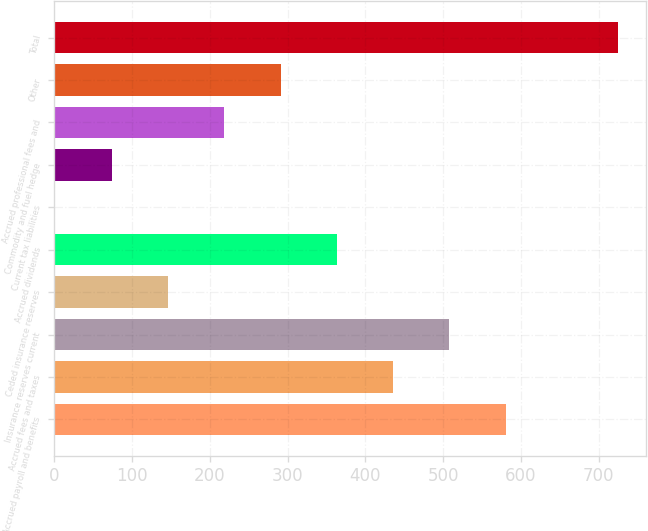Convert chart. <chart><loc_0><loc_0><loc_500><loc_500><bar_chart><fcel>Accrued payroll and benefits<fcel>Accrued fees and taxes<fcel>Insurance reserves current<fcel>Ceded insurance reserves<fcel>Accrued dividends<fcel>Current tax liabilities<fcel>Commodity and fuel hedge<fcel>Accrued professional fees and<fcel>Other<fcel>Total<nl><fcel>580.28<fcel>435.56<fcel>507.92<fcel>146.12<fcel>363.2<fcel>1.4<fcel>73.76<fcel>218.48<fcel>290.84<fcel>725<nl></chart> 